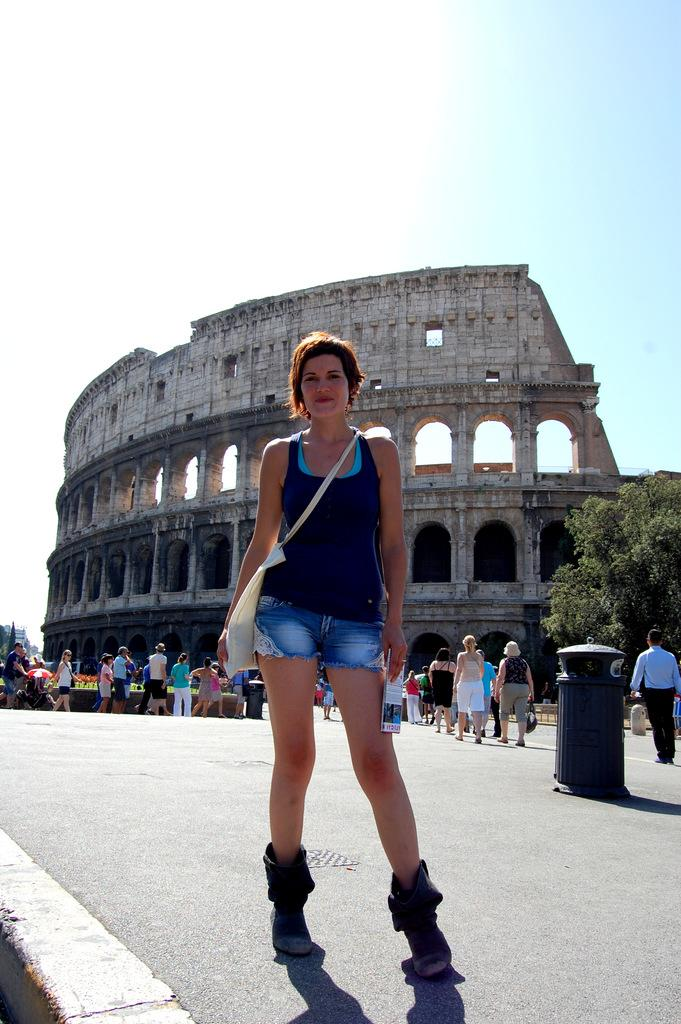Who is the main subject in the image? There is a lady in the image. What is the lady doing in the image? The lady is standing on the road. Are there any other people visible in the image? Yes, there are people behind the lady. What can be seen in the background of the image? There is a building in the background of the image. What color is the lady's toothbrush in the image? There is no toothbrush present in the image, and therefore no such detail can be observed. 